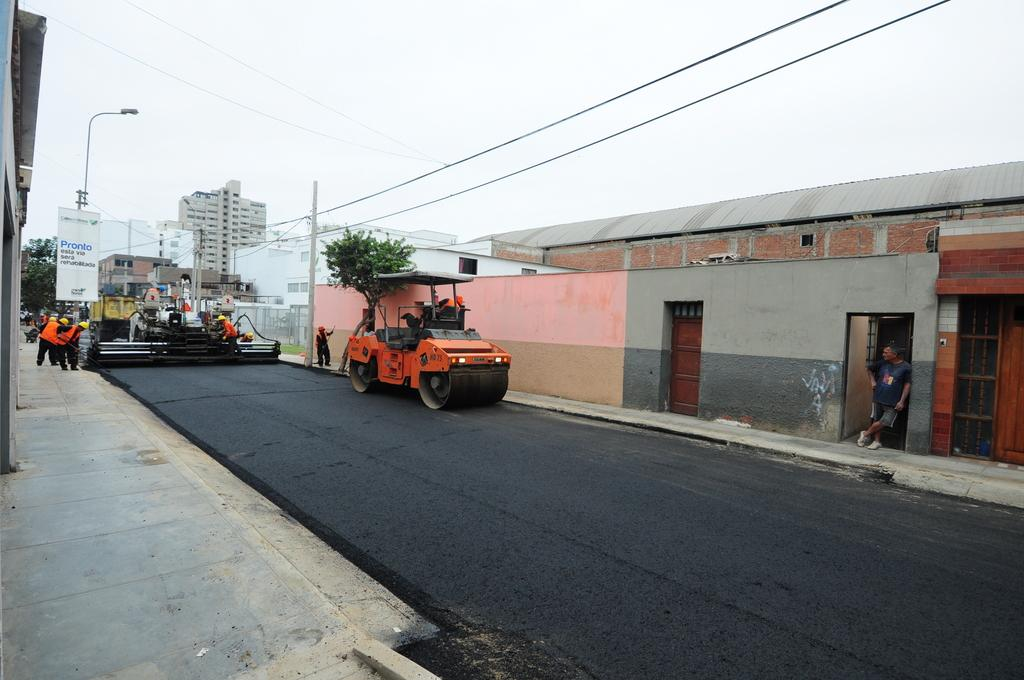What activity are the people in the image engaged in? The people in the image are laying road. What structure can be seen in the background of the image? There is a building in the image. What type of infrastructure is present in the image? Electric wires and poles are visible in the image. What type of lighting is present in the image? There is a street light in the image. What type of breakfast is being served on the island in the image? There is no island or breakfast present in the image; it features people laying road with a building, electric wires, poles, and a street light in the background. 